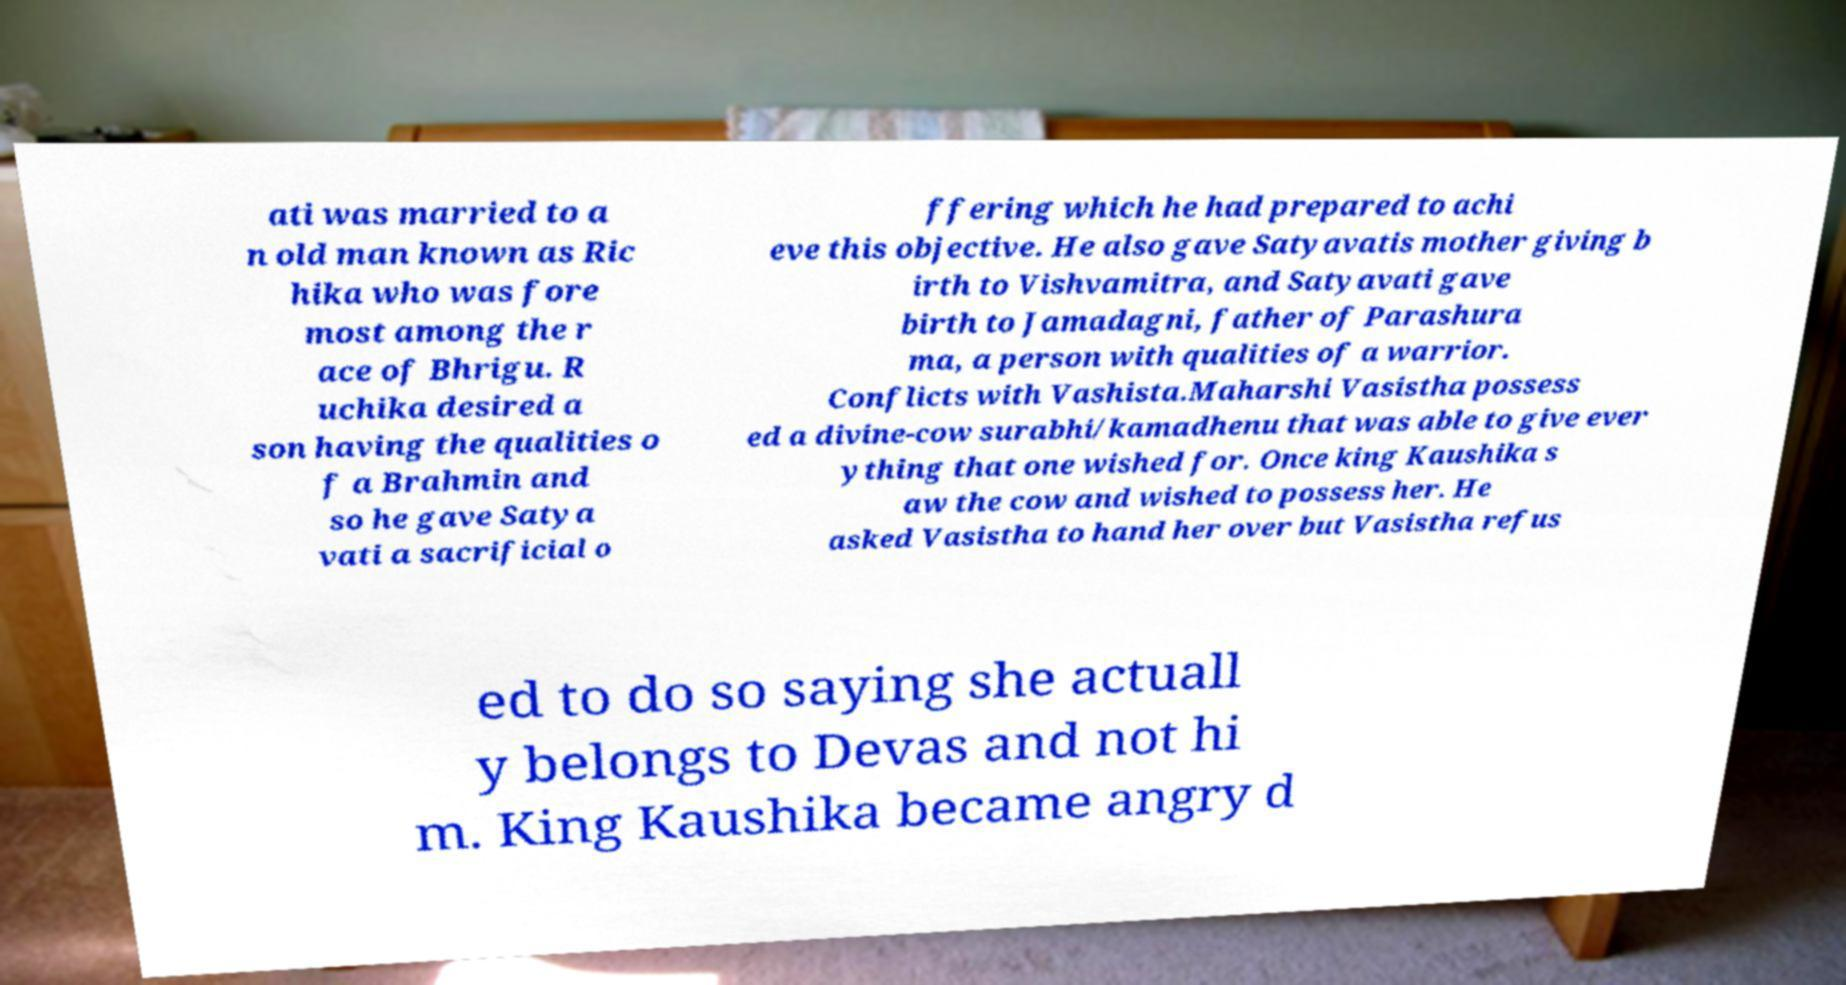Could you assist in decoding the text presented in this image and type it out clearly? ati was married to a n old man known as Ric hika who was fore most among the r ace of Bhrigu. R uchika desired a son having the qualities o f a Brahmin and so he gave Satya vati a sacrificial o ffering which he had prepared to achi eve this objective. He also gave Satyavatis mother giving b irth to Vishvamitra, and Satyavati gave birth to Jamadagni, father of Parashura ma, a person with qualities of a warrior. Conflicts with Vashista.Maharshi Vasistha possess ed a divine-cow surabhi/kamadhenu that was able to give ever ything that one wished for. Once king Kaushika s aw the cow and wished to possess her. He asked Vasistha to hand her over but Vasistha refus ed to do so saying she actuall y belongs to Devas and not hi m. King Kaushika became angry d 